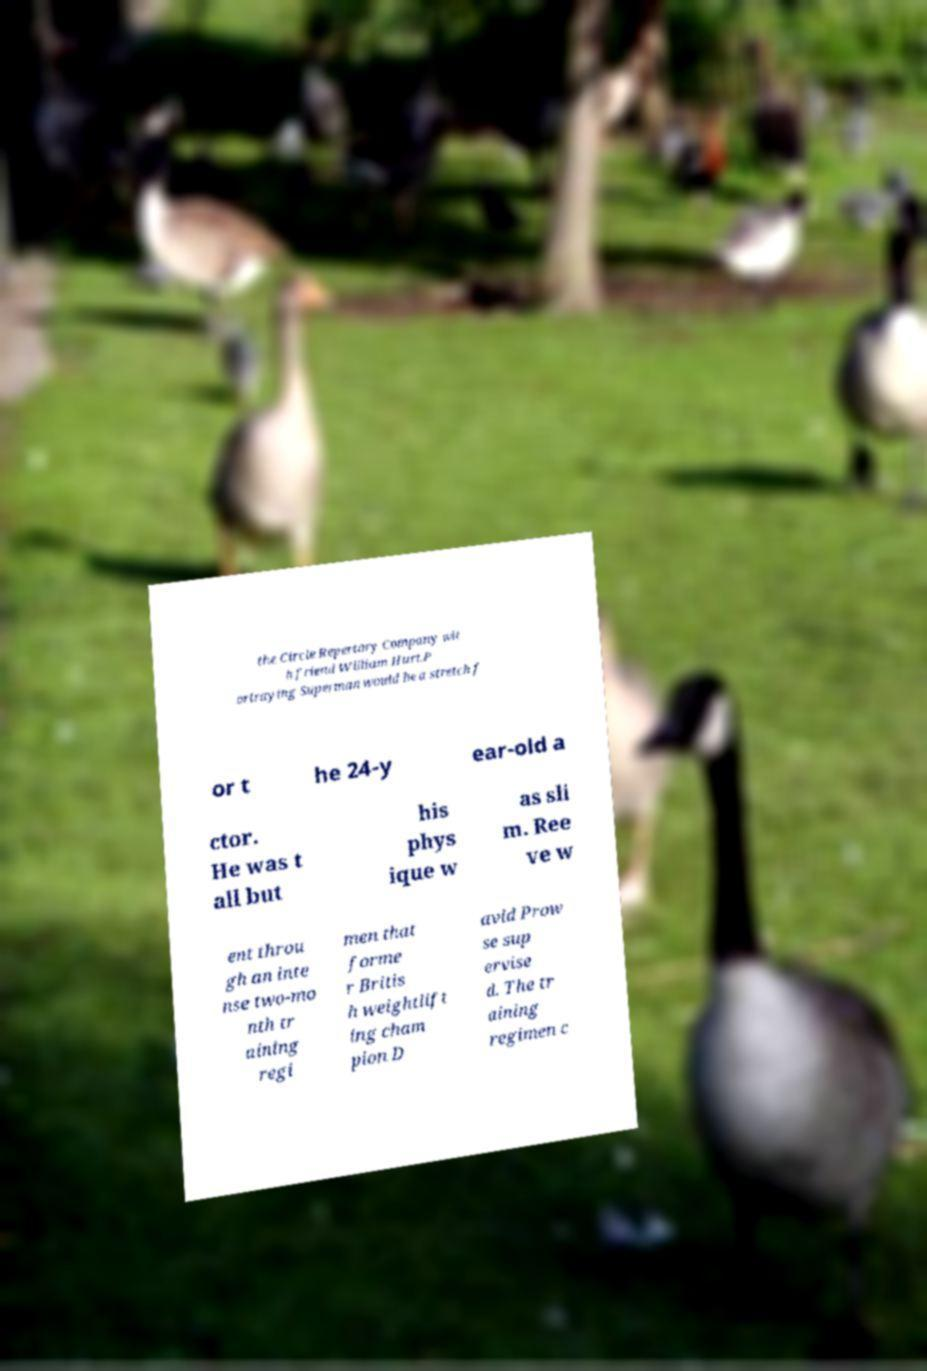Could you extract and type out the text from this image? the Circle Repertory Company wit h friend William Hurt.P ortraying Superman would be a stretch f or t he 24-y ear-old a ctor. He was t all but his phys ique w as sli m. Ree ve w ent throu gh an inte nse two-mo nth tr aining regi men that forme r Britis h weightlift ing cham pion D avid Prow se sup ervise d. The tr aining regimen c 